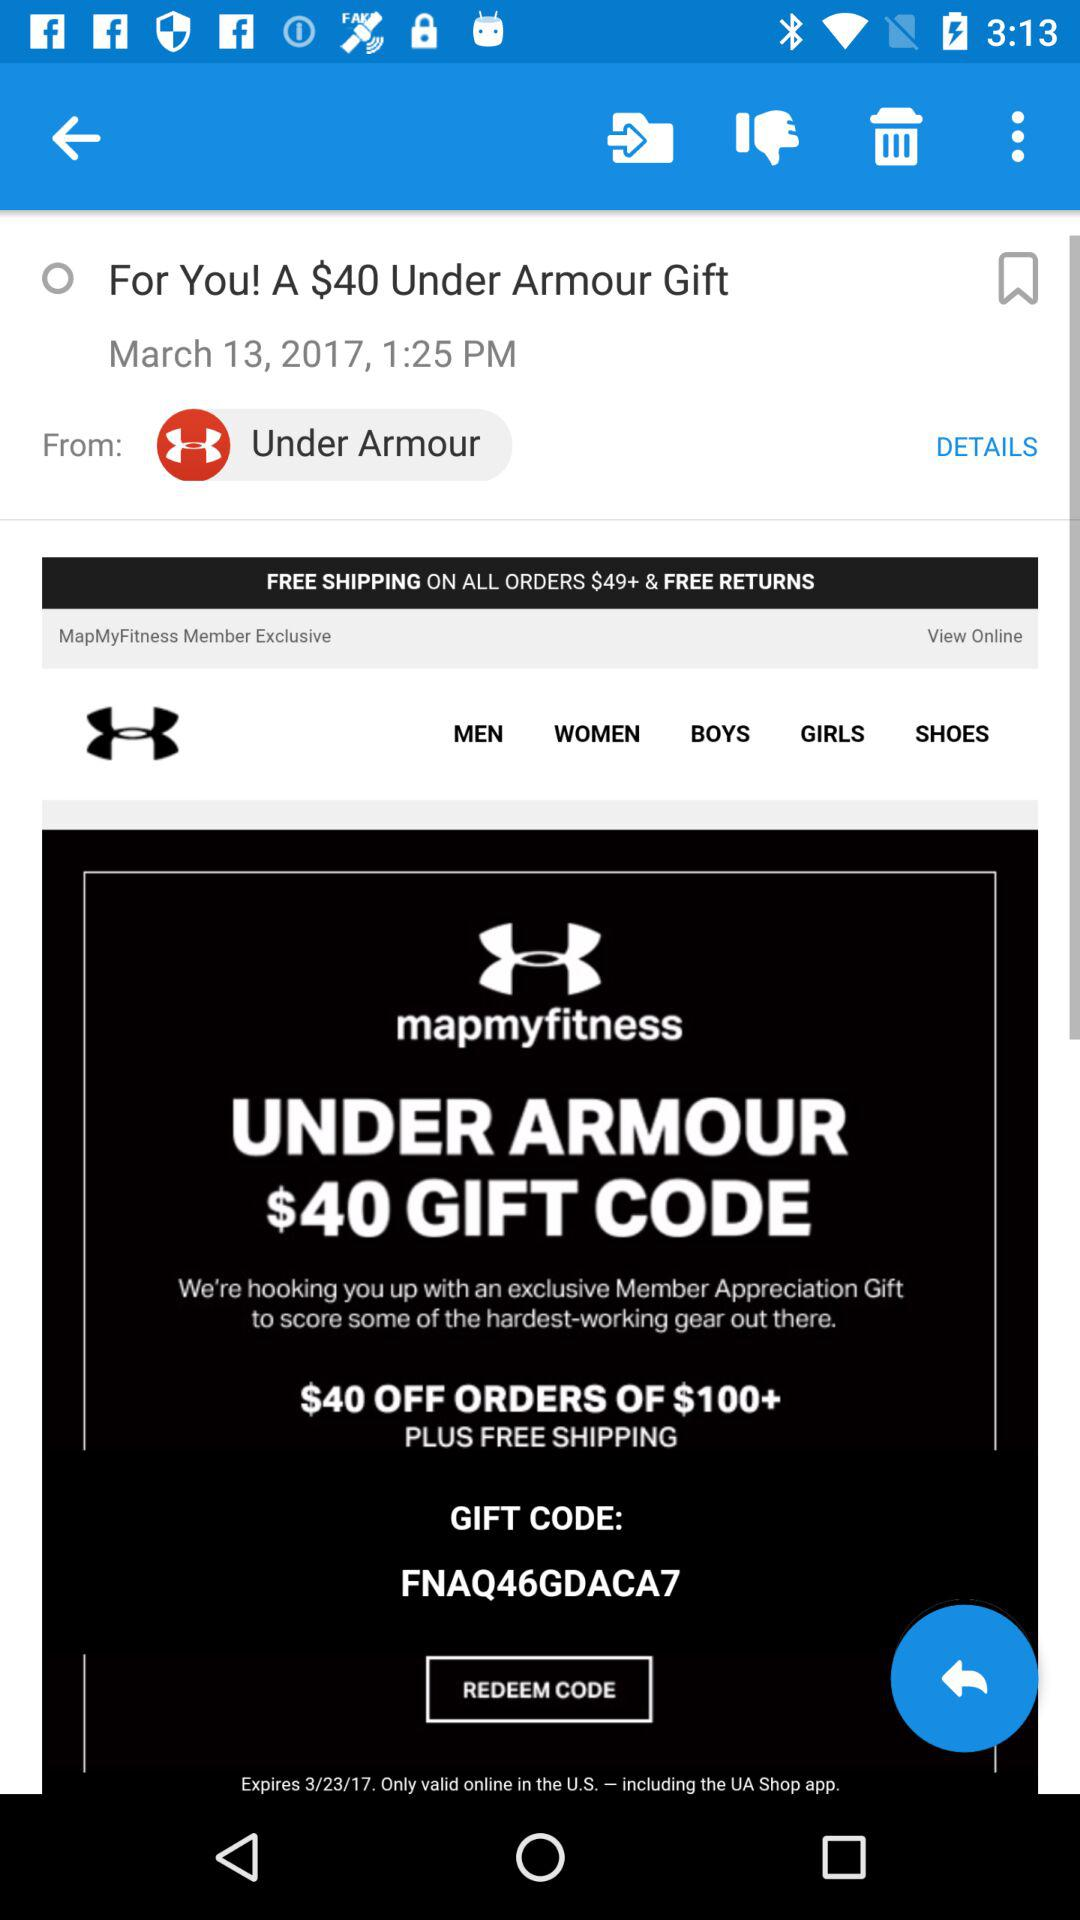At what time did Under Armour update this offer? Under Armour updated this offer at 1:25 PM. 